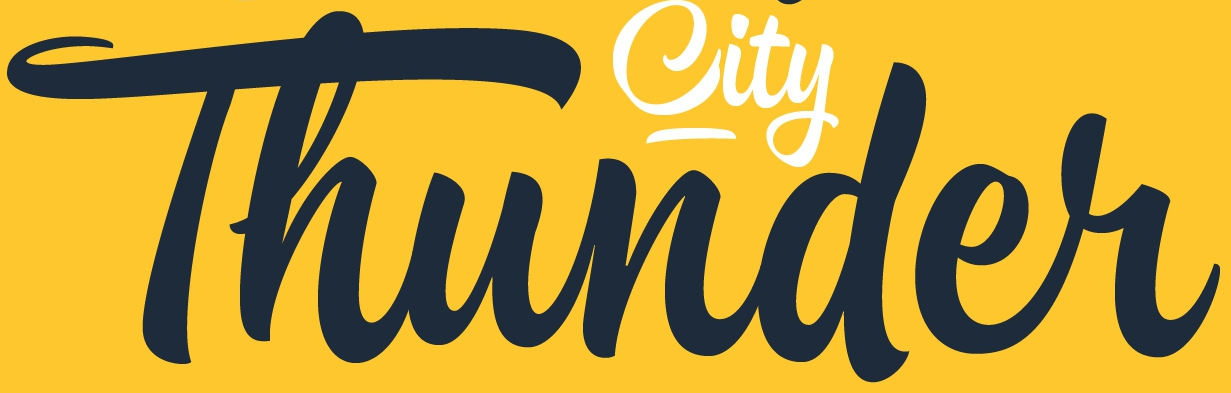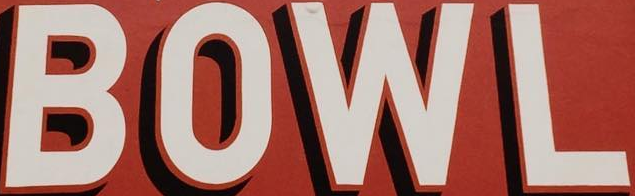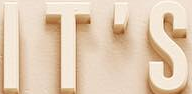Read the text content from these images in order, separated by a semicolon. Thunder; BOWL; IT'S 